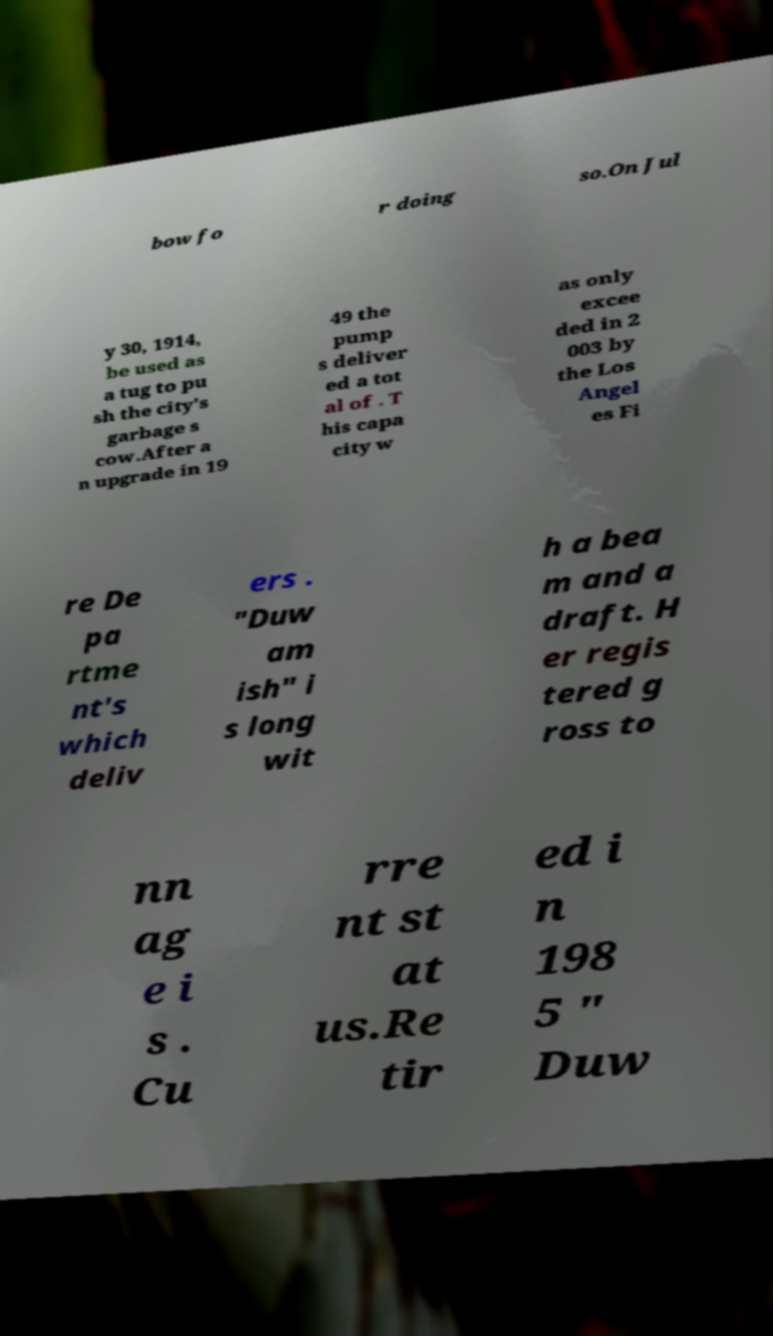Could you assist in decoding the text presented in this image and type it out clearly? bow fo r doing so.On Jul y 30, 1914, be used as a tug to pu sh the city's garbage s cow.After a n upgrade in 19 49 the pump s deliver ed a tot al of . T his capa city w as only excee ded in 2 003 by the Los Angel es Fi re De pa rtme nt's which deliv ers . "Duw am ish" i s long wit h a bea m and a draft. H er regis tered g ross to nn ag e i s . Cu rre nt st at us.Re tir ed i n 198 5 " Duw 